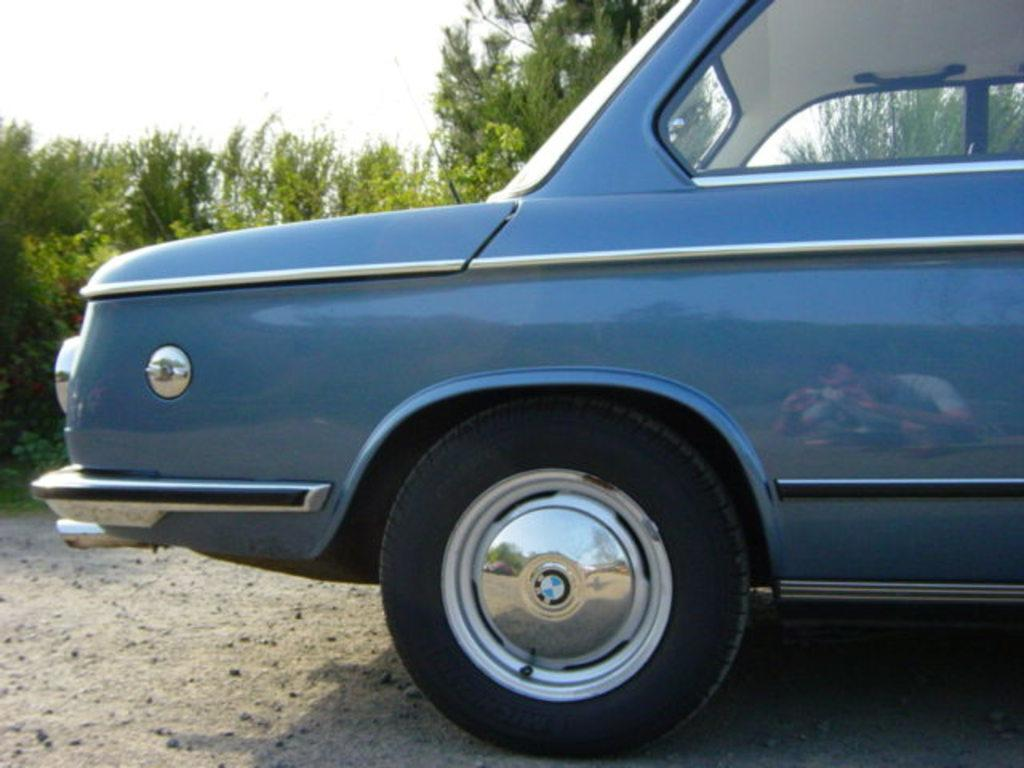What is the main subject of the image? There is a vehicle in the image. What type of environment is depicted in the image? The image shows grass, trees, and a road, suggesting a natural setting. What can be seen in the sky in the image? There is a sky visible in the image. Can you describe the reflection in the image? In the reflection, there is a person wearing clothes. How many apples can be seen hanging from the trees in the image? There are no apples visible in the image; only trees are present. What type of amusement can be seen in the image? There is no amusement depicted in the image; it features a vehicle, grass, trees, a road, and a sky. 